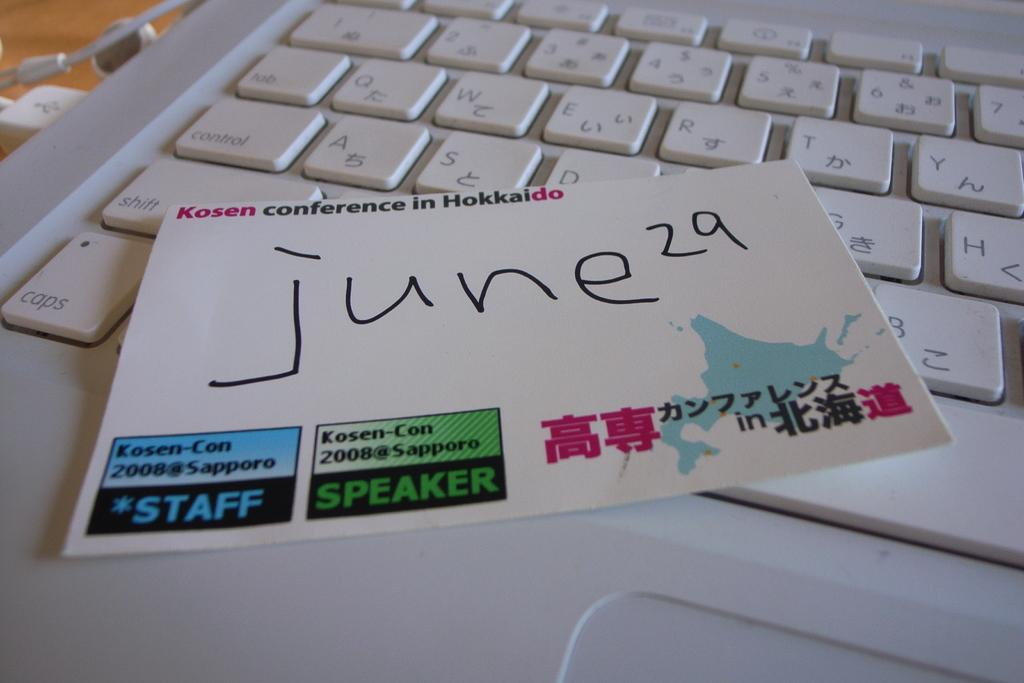<image>
Describe the image concisely. a keyboard that has a card on it that has 'june 29' written on it 